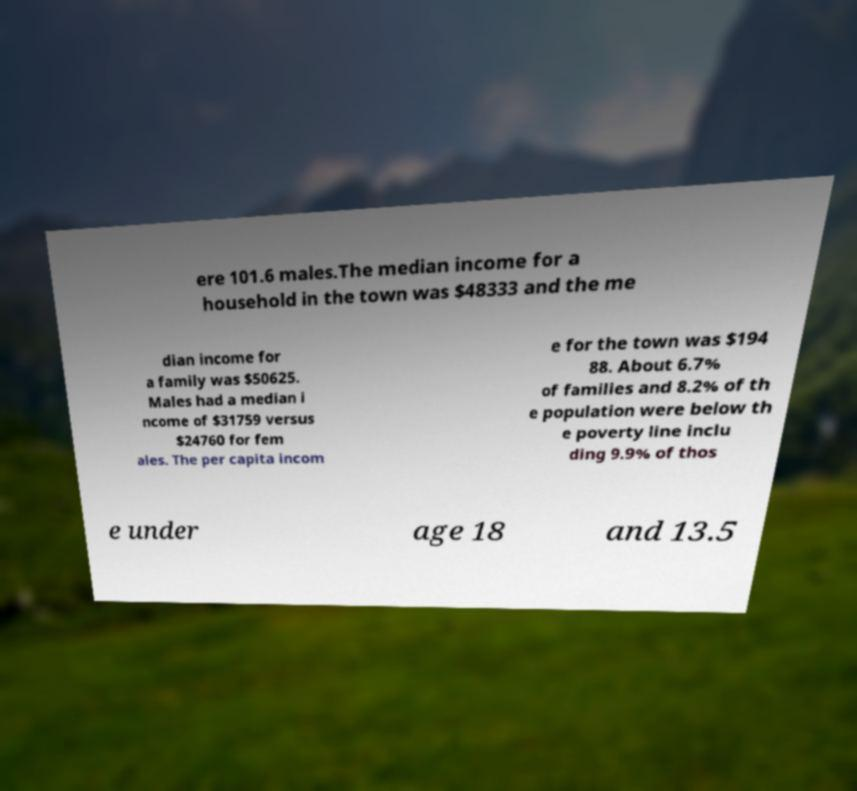For documentation purposes, I need the text within this image transcribed. Could you provide that? ere 101.6 males.The median income for a household in the town was $48333 and the me dian income for a family was $50625. Males had a median i ncome of $31759 versus $24760 for fem ales. The per capita incom e for the town was $194 88. About 6.7% of families and 8.2% of th e population were below th e poverty line inclu ding 9.9% of thos e under age 18 and 13.5 